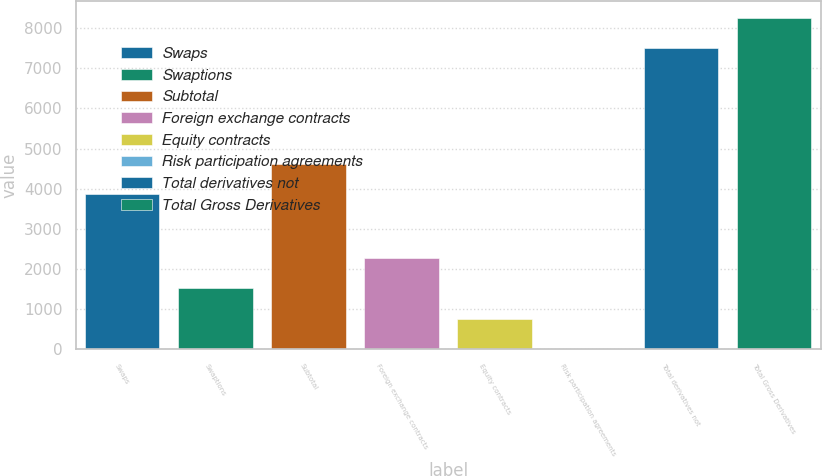<chart> <loc_0><loc_0><loc_500><loc_500><bar_chart><fcel>Swaps<fcel>Swaptions<fcel>Subtotal<fcel>Foreign exchange contracts<fcel>Equity contracts<fcel>Risk participation agreements<fcel>Total derivatives not<fcel>Total Gross Derivatives<nl><fcel>3863<fcel>1525.2<fcel>4623.1<fcel>2285.3<fcel>765.1<fcel>5<fcel>7490<fcel>8250.1<nl></chart> 